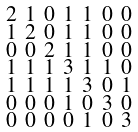Convert formula to latex. <formula><loc_0><loc_0><loc_500><loc_500>\begin{smallmatrix} 2 & 1 & 0 & 1 & 1 & 0 & 0 \\ 1 & 2 & 0 & 1 & 1 & 0 & 0 \\ 0 & 0 & 2 & 1 & 1 & 0 & 0 \\ 1 & 1 & 1 & 3 & 1 & 1 & 0 \\ 1 & 1 & 1 & 1 & 3 & 0 & 1 \\ 0 & 0 & 0 & 1 & 0 & 3 & 0 \\ 0 & 0 & 0 & 0 & 1 & 0 & 3 \end{smallmatrix}</formula> 